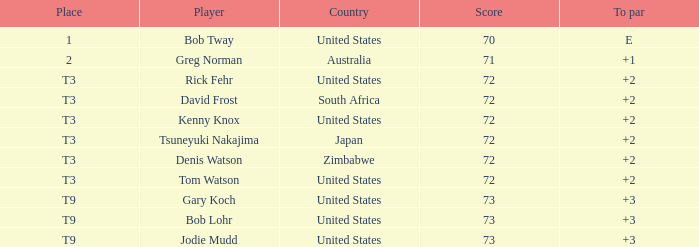Who scored more than 72? Gary Koch, Bob Lohr, Jodie Mudd. I'm looking to parse the entire table for insights. Could you assist me with that? {'header': ['Place', 'Player', 'Country', 'Score', 'To par'], 'rows': [['1', 'Bob Tway', 'United States', '70', 'E'], ['2', 'Greg Norman', 'Australia', '71', '+1'], ['T3', 'Rick Fehr', 'United States', '72', '+2'], ['T3', 'David Frost', 'South Africa', '72', '+2'], ['T3', 'Kenny Knox', 'United States', '72', '+2'], ['T3', 'Tsuneyuki Nakajima', 'Japan', '72', '+2'], ['T3', 'Denis Watson', 'Zimbabwe', '72', '+2'], ['T3', 'Tom Watson', 'United States', '72', '+2'], ['T9', 'Gary Koch', 'United States', '73', '+3'], ['T9', 'Bob Lohr', 'United States', '73', '+3'], ['T9', 'Jodie Mudd', 'United States', '73', '+3']]} 